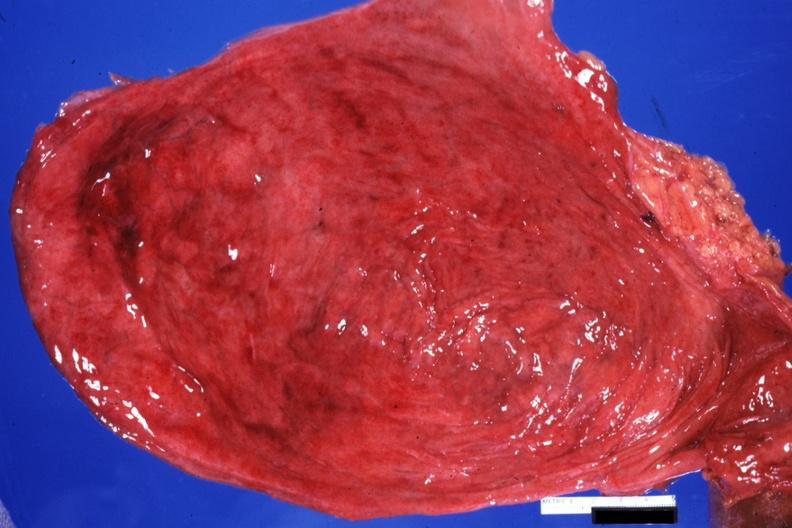what is present?
Answer the question using a single word or phrase. Urinary 